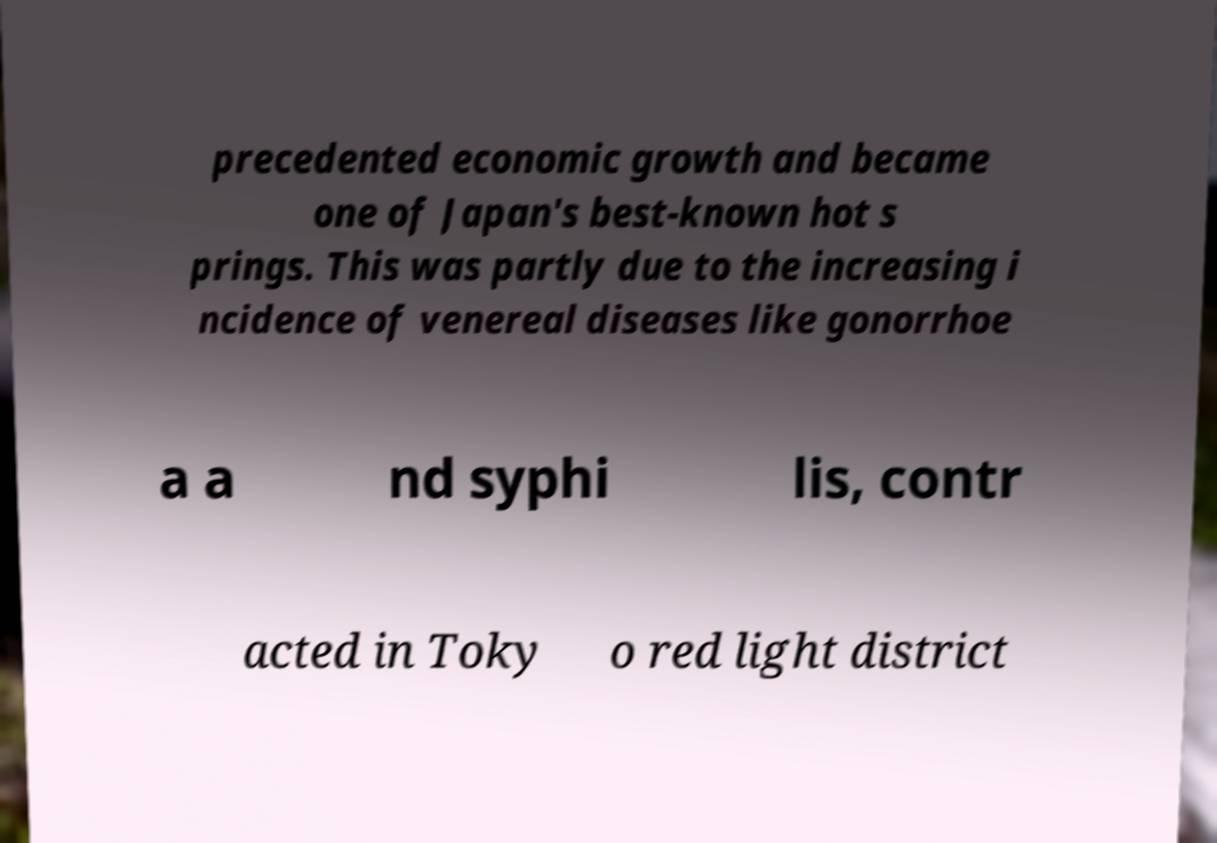Please read and relay the text visible in this image. What does it say? precedented economic growth and became one of Japan's best-known hot s prings. This was partly due to the increasing i ncidence of venereal diseases like gonorrhoe a a nd syphi lis, contr acted in Toky o red light district 